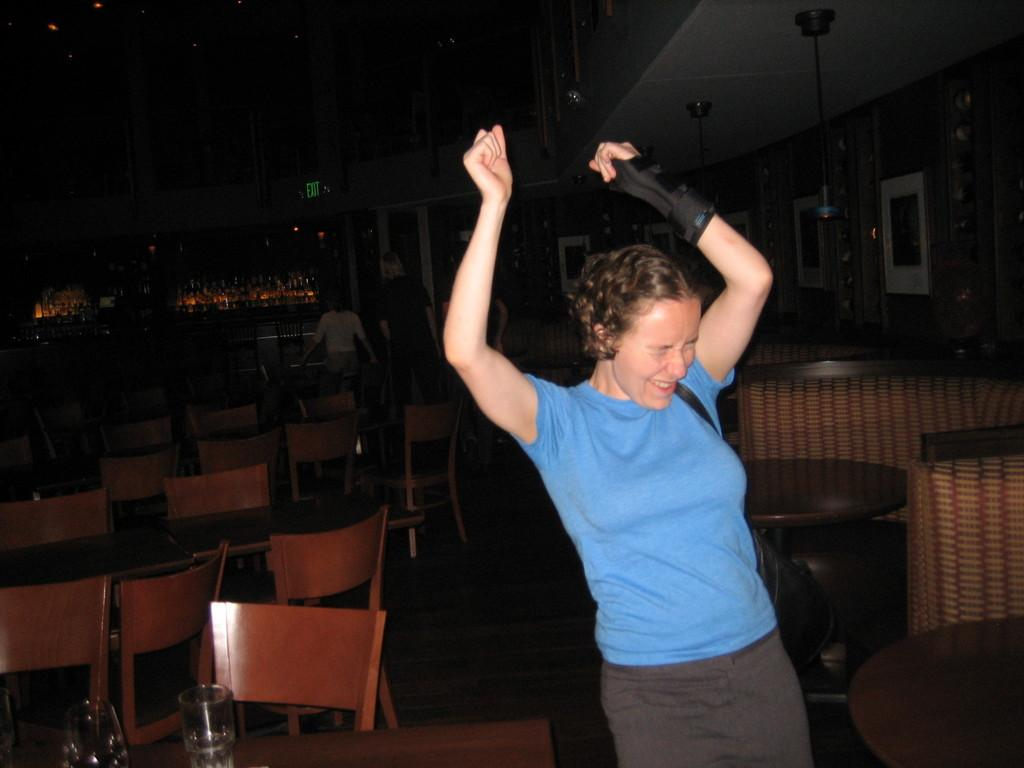Who is present in the image? There is a woman in the image. What is the woman wearing? The woman is wearing a blue top. What is the woman's facial expression? The woman is smiling. What can be seen in the background of the image? There are chairs and tables in the background of the image. How many people are in the background of the image? There are two persons in the background of the image. What type of rice is being served in the bucket in the image? There is no rice or bucket present in the image. 